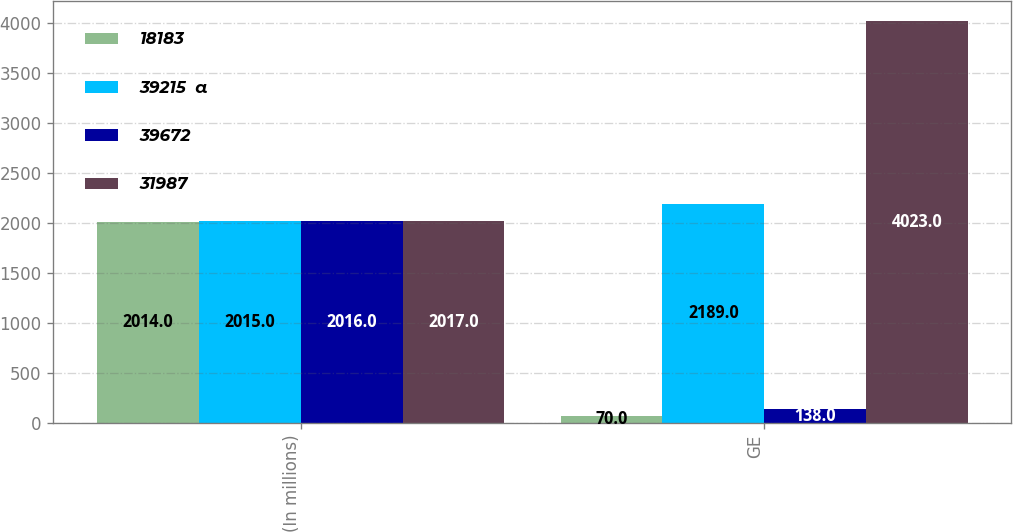<chart> <loc_0><loc_0><loc_500><loc_500><stacked_bar_chart><ecel><fcel>(In millions)<fcel>GE<nl><fcel>18183<fcel>2014<fcel>70<nl><fcel>39215  a<fcel>2015<fcel>2189<nl><fcel>39672<fcel>2016<fcel>138<nl><fcel>31987<fcel>2017<fcel>4023<nl></chart> 